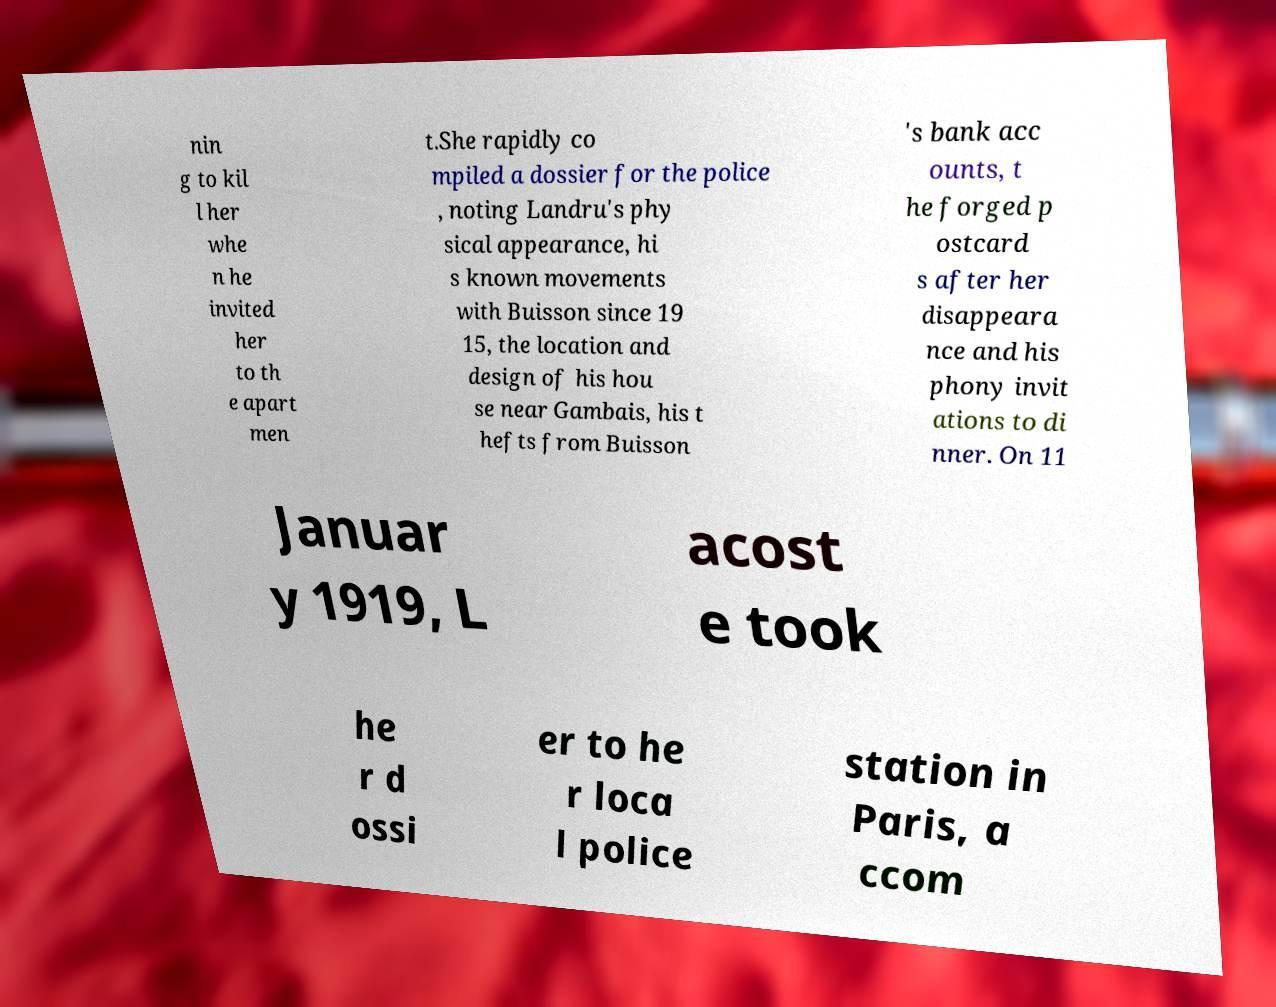There's text embedded in this image that I need extracted. Can you transcribe it verbatim? nin g to kil l her whe n he invited her to th e apart men t.She rapidly co mpiled a dossier for the police , noting Landru's phy sical appearance, hi s known movements with Buisson since 19 15, the location and design of his hou se near Gambais, his t hefts from Buisson 's bank acc ounts, t he forged p ostcard s after her disappeara nce and his phony invit ations to di nner. On 11 Januar y 1919, L acost e took he r d ossi er to he r loca l police station in Paris, a ccom 